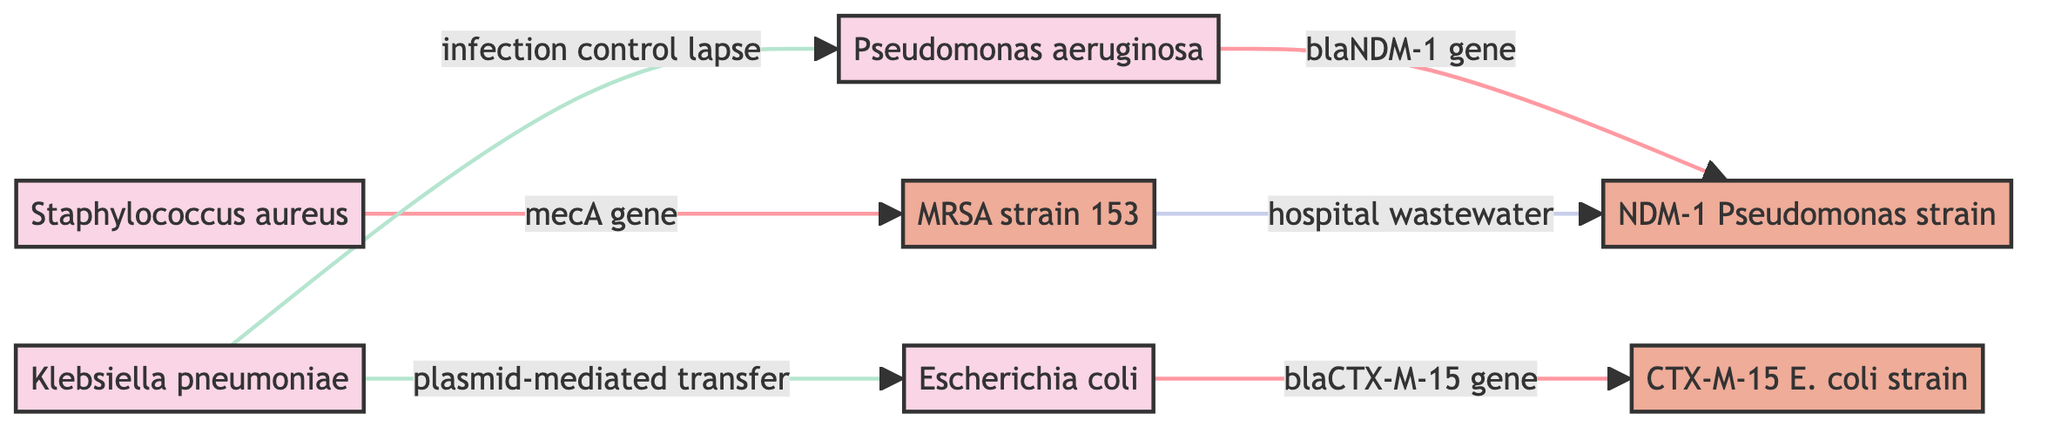What is the total number of bacterial species in the diagram? The diagram includes four bacterial species: Escherichia coli, Staphylococcus aureus, Pseudomonas aeruginosa, and Klebsiella pneumoniae. Counting these gives a total of four species.
Answer: 4 Which strain is linked to the mecA gene? The mecA gene is linked to the MRSA strain 153, which can be observed as a direct connection from Staphylococcus aureus to the strain.
Answer: MRSA strain 153 How many genes are indicated in the diagram? The diagram indicates three genes: blaCTX-M-15 gene, mecA gene, and blaNDM-1 gene. After counting these distinct genes represented in the connections, the total comes to three.
Answer: 3 What type of transfer is associated with Klebsiella pneumoniae? Klebsiella pneumoniae is associated with "plasmid-mediated transfer," which can be seen as a direct relationship in the diagram.
Answer: plasmid-mediated transfer Which strain is connected to hospital wastewater? The connection to hospital wastewater is linked to the NDM-1 Pseudomonas strain, as indicated directly in the diagram.
Answer: NDM-1 Pseudomonas strain What type of environmental link does the diagram illustrate? The diagram illustrates a "hospital wastewater" environmental link, which can be identified under the connections regarding strain interactions.
Answer: hospital wastewater What is the relationship between Klebsiella pneumoniae and Escherichia coli? The relationship is characterized by "infection control lapse," which indicates a transmission link from Klebsiella pneumoniae to Pseudomonas aeruginosa via Escherichia coli.
Answer: infection control lapse How many total connections are there in the diagram? There are six total connections (links) among the species and strains as shown in the diagram. By counting each arrow/link between the nodes, we find the total number to be six.
Answer: 6 